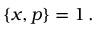<formula> <loc_0><loc_0><loc_500><loc_500>\{ x , p \} = 1 \, .</formula> 